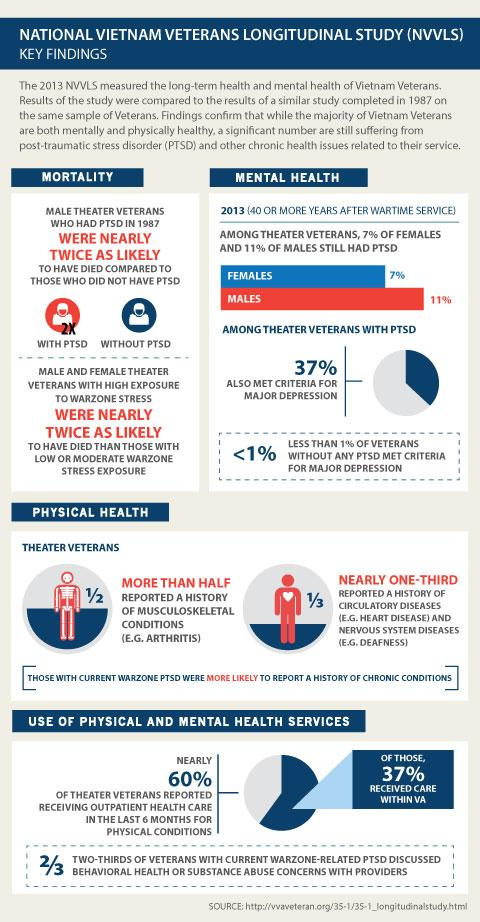Specify some key components in this picture. A study found that 37% of veterans with post-traumatic stress disorder (PTSD) also met criteria for major depression. According to the study, less than 1% of theatre veterans without post-traumatic stress disorder (PTSD) met the criteria for major depression. The mortality rate is higher among individuals with PTSD compared to those without PTSD. Specifically, those with PTSD have a higher risk of mortality. According to recent statistics, out of every three veterans, approximately 33.3% have a history of circulatory diseases and nervous system diseases. A common nervous system disease experienced by theater veterans is deafness. 